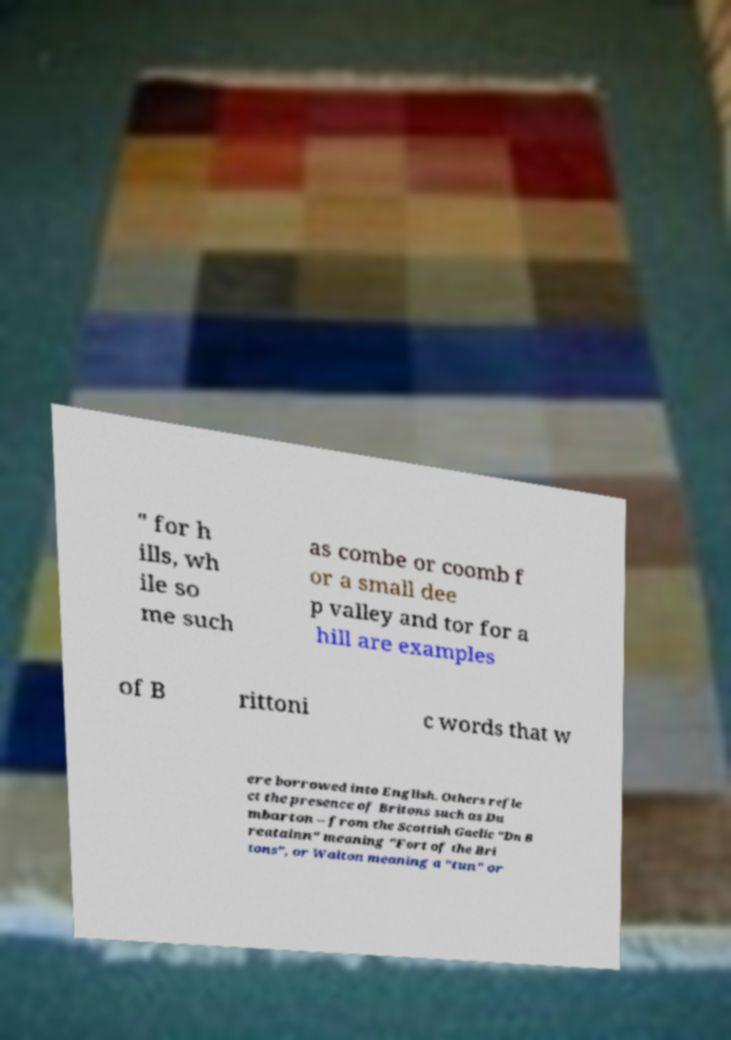Could you assist in decoding the text presented in this image and type it out clearly? " for h ills, wh ile so me such as combe or coomb f or a small dee p valley and tor for a hill are examples of B rittoni c words that w ere borrowed into English. Others refle ct the presence of Britons such as Du mbarton – from the Scottish Gaelic "Dn B reatainn" meaning "Fort of the Bri tons", or Walton meaning a "tun" or 